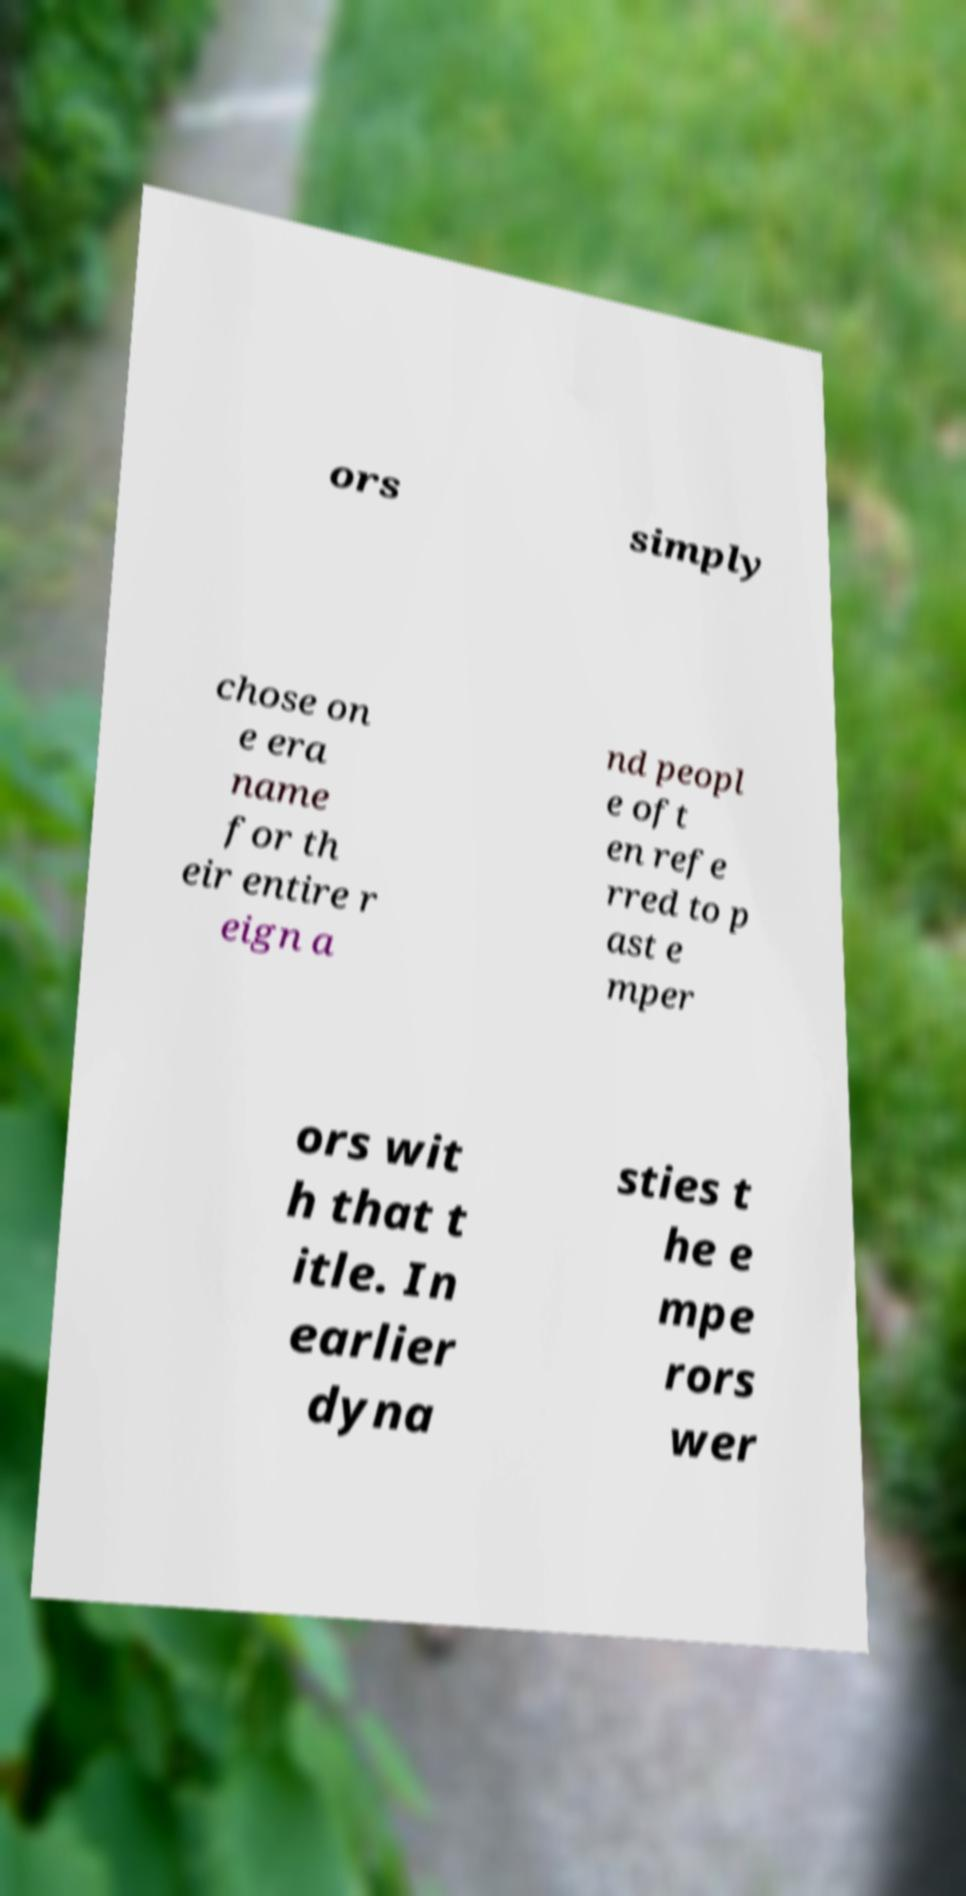Could you assist in decoding the text presented in this image and type it out clearly? ors simply chose on e era name for th eir entire r eign a nd peopl e oft en refe rred to p ast e mper ors wit h that t itle. In earlier dyna sties t he e mpe rors wer 